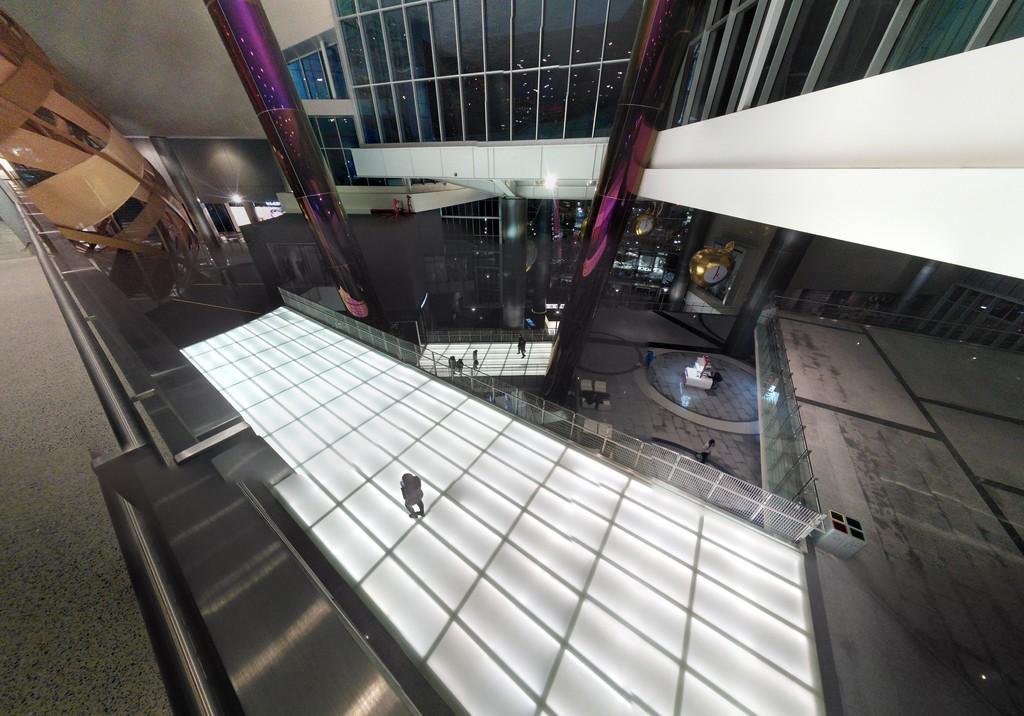Describe this image in one or two sentences. In the image we can see inside of the building and few people are standing and walking. 